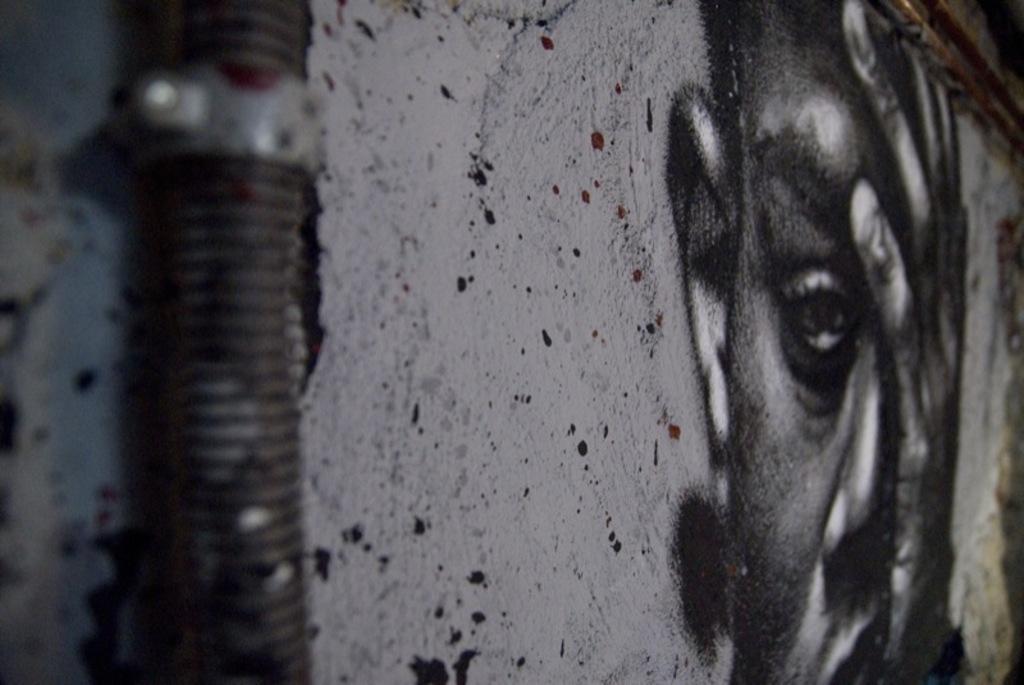Describe this image in one or two sentences. In the picture we can see a wall with a painting of a man's face on the wall and we can also see a pipe which is fixed to the wall. 